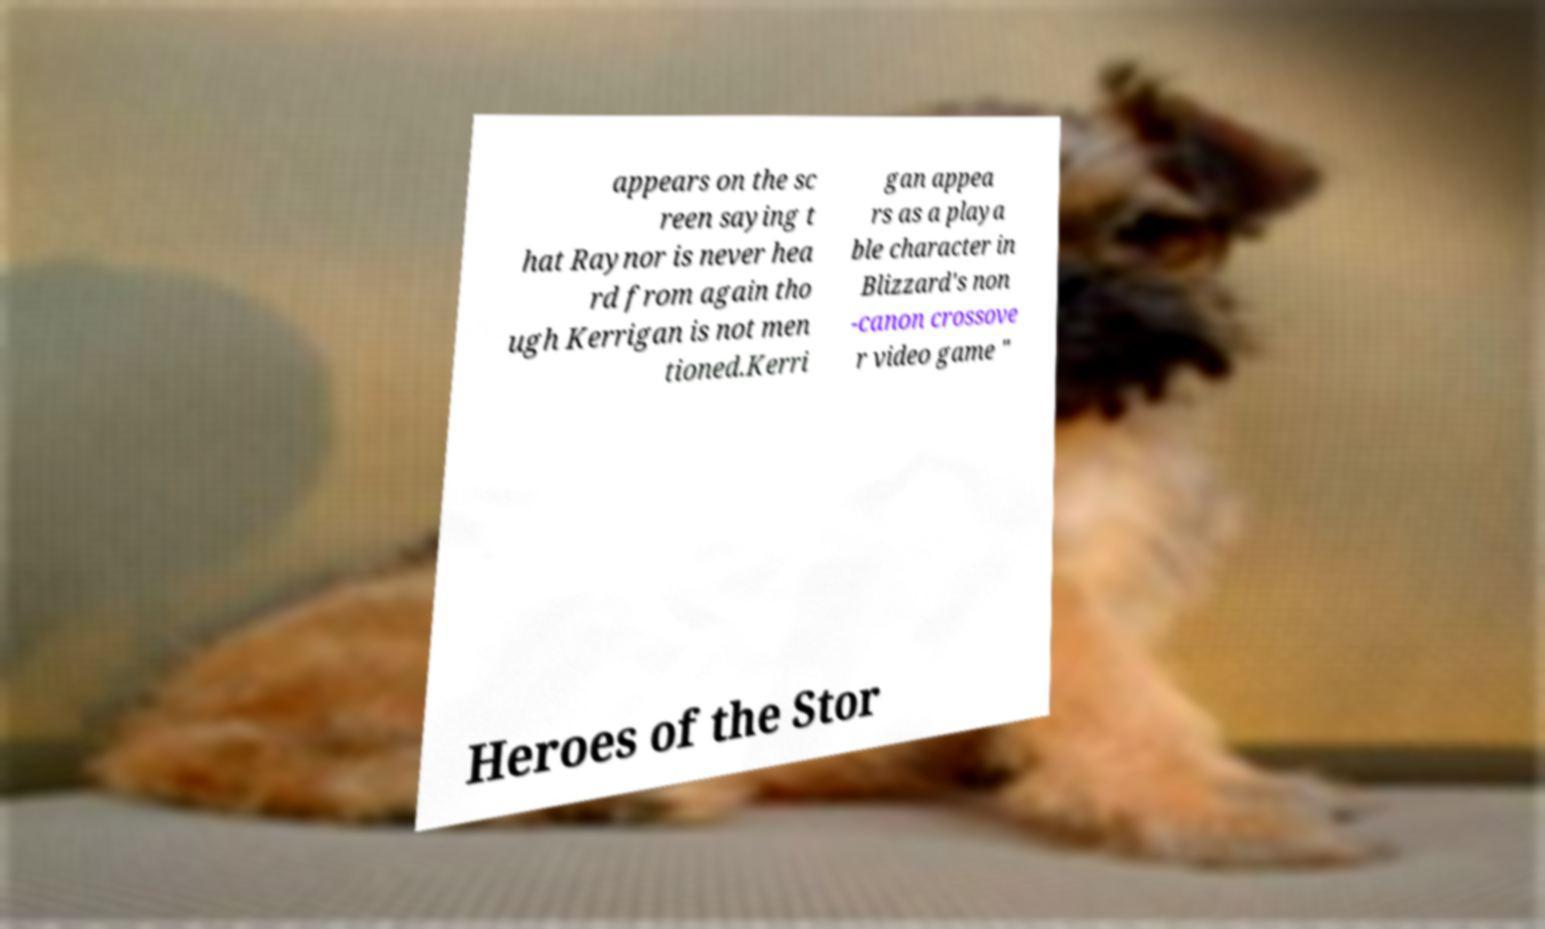Could you assist in decoding the text presented in this image and type it out clearly? appears on the sc reen saying t hat Raynor is never hea rd from again tho ugh Kerrigan is not men tioned.Kerri gan appea rs as a playa ble character in Blizzard's non -canon crossove r video game " Heroes of the Stor 